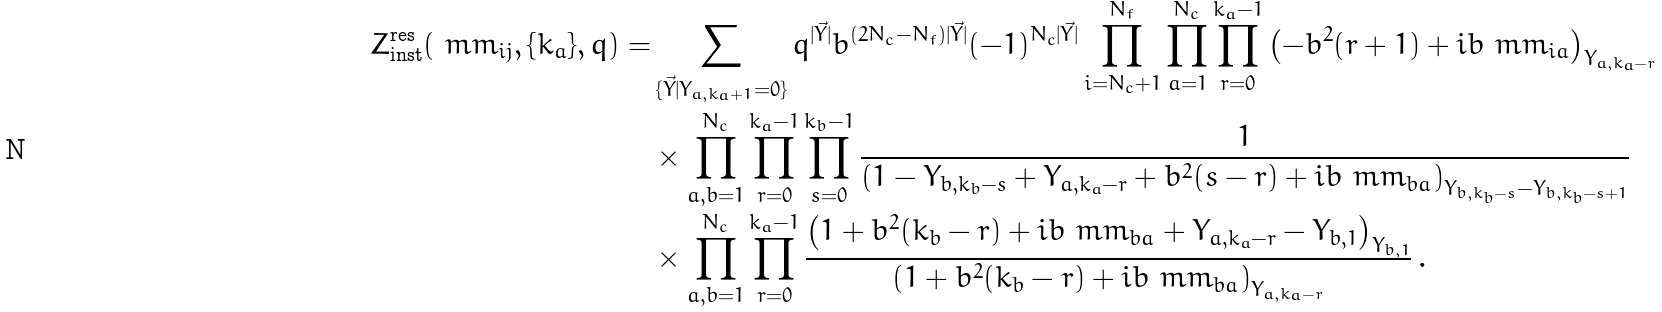<formula> <loc_0><loc_0><loc_500><loc_500>Z ^ { \text {res} } _ { \text {inst} } ( \ m m _ { i j } , \{ k _ { a } \} , q ) = & \sum _ { \{ \vec { Y } | Y _ { a , k _ { a } + 1 } = 0 \} } q ^ { | \vec { Y } | } b ^ { ( 2 N _ { c } - N _ { f } ) { | \vec { Y } | } } ( - 1 ) ^ { N _ { c } | \vec { Y } | } \prod _ { i = N _ { c } + 1 } ^ { N _ { f } } \prod _ { a = 1 } ^ { N _ { c } } \prod _ { r = 0 } ^ { k _ { a } - 1 } \left ( - b ^ { 2 } ( r + 1 ) + i b \ m m _ { i a } \right ) _ { Y _ { a , k _ { a } - r } } \\ & \times \prod _ { a , b = 1 } ^ { N _ { c } } \prod _ { r = 0 } ^ { k _ { a } - 1 } \prod _ { s = 0 } ^ { k _ { b } - 1 } \frac { 1 } { \left ( 1 - Y _ { b , k _ { b } - s } + Y _ { a , k _ { a } - r } + b ^ { 2 } ( s - r ) + i b \ m m _ { b a } \right ) _ { Y _ { b , k _ { b } - s } - Y _ { b , k _ { b } - s + 1 } } } \\ & \times \prod _ { a , b = 1 } ^ { N _ { c } } \prod _ { r = 0 } ^ { k _ { a } - 1 } \frac { \left ( 1 + b ^ { 2 } ( k _ { b } - r ) + i b \ m m _ { b a } + Y _ { a , k _ { a } - r } - Y _ { b , 1 } \right ) _ { Y _ { b , 1 } } } { \left ( 1 + b ^ { 2 } ( k _ { b } - r ) + i b \ m m _ { b a } \right ) _ { Y _ { a , k _ { a } - r } } } \, .</formula> 